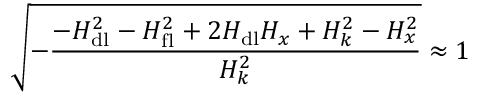<formula> <loc_0><loc_0><loc_500><loc_500>\sqrt { - \frac { - H _ { d l } ^ { 2 } - H _ { f l } ^ { 2 } + 2 H _ { d l } H _ { x } + H _ { k } ^ { 2 } - H _ { x } ^ { 2 } } { H _ { k } ^ { 2 } } } \approx 1</formula> 